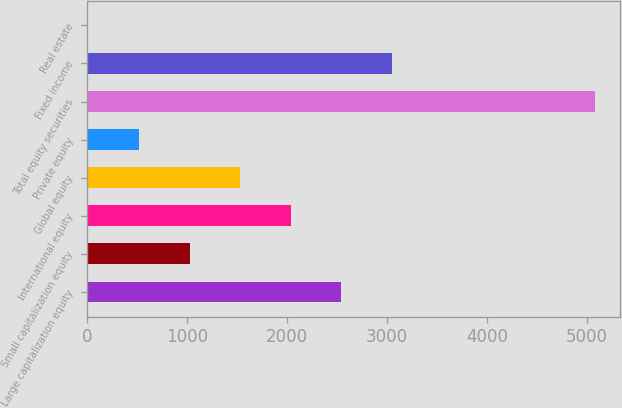<chart> <loc_0><loc_0><loc_500><loc_500><bar_chart><fcel>Large capitalization equity<fcel>Small capitalization equity<fcel>International equity<fcel>Global equity<fcel>Private equity<fcel>Total equity securities<fcel>Fixed income<fcel>Real estate<nl><fcel>2542.5<fcel>1023<fcel>2036<fcel>1529.5<fcel>516.5<fcel>5075<fcel>3049<fcel>10<nl></chart> 